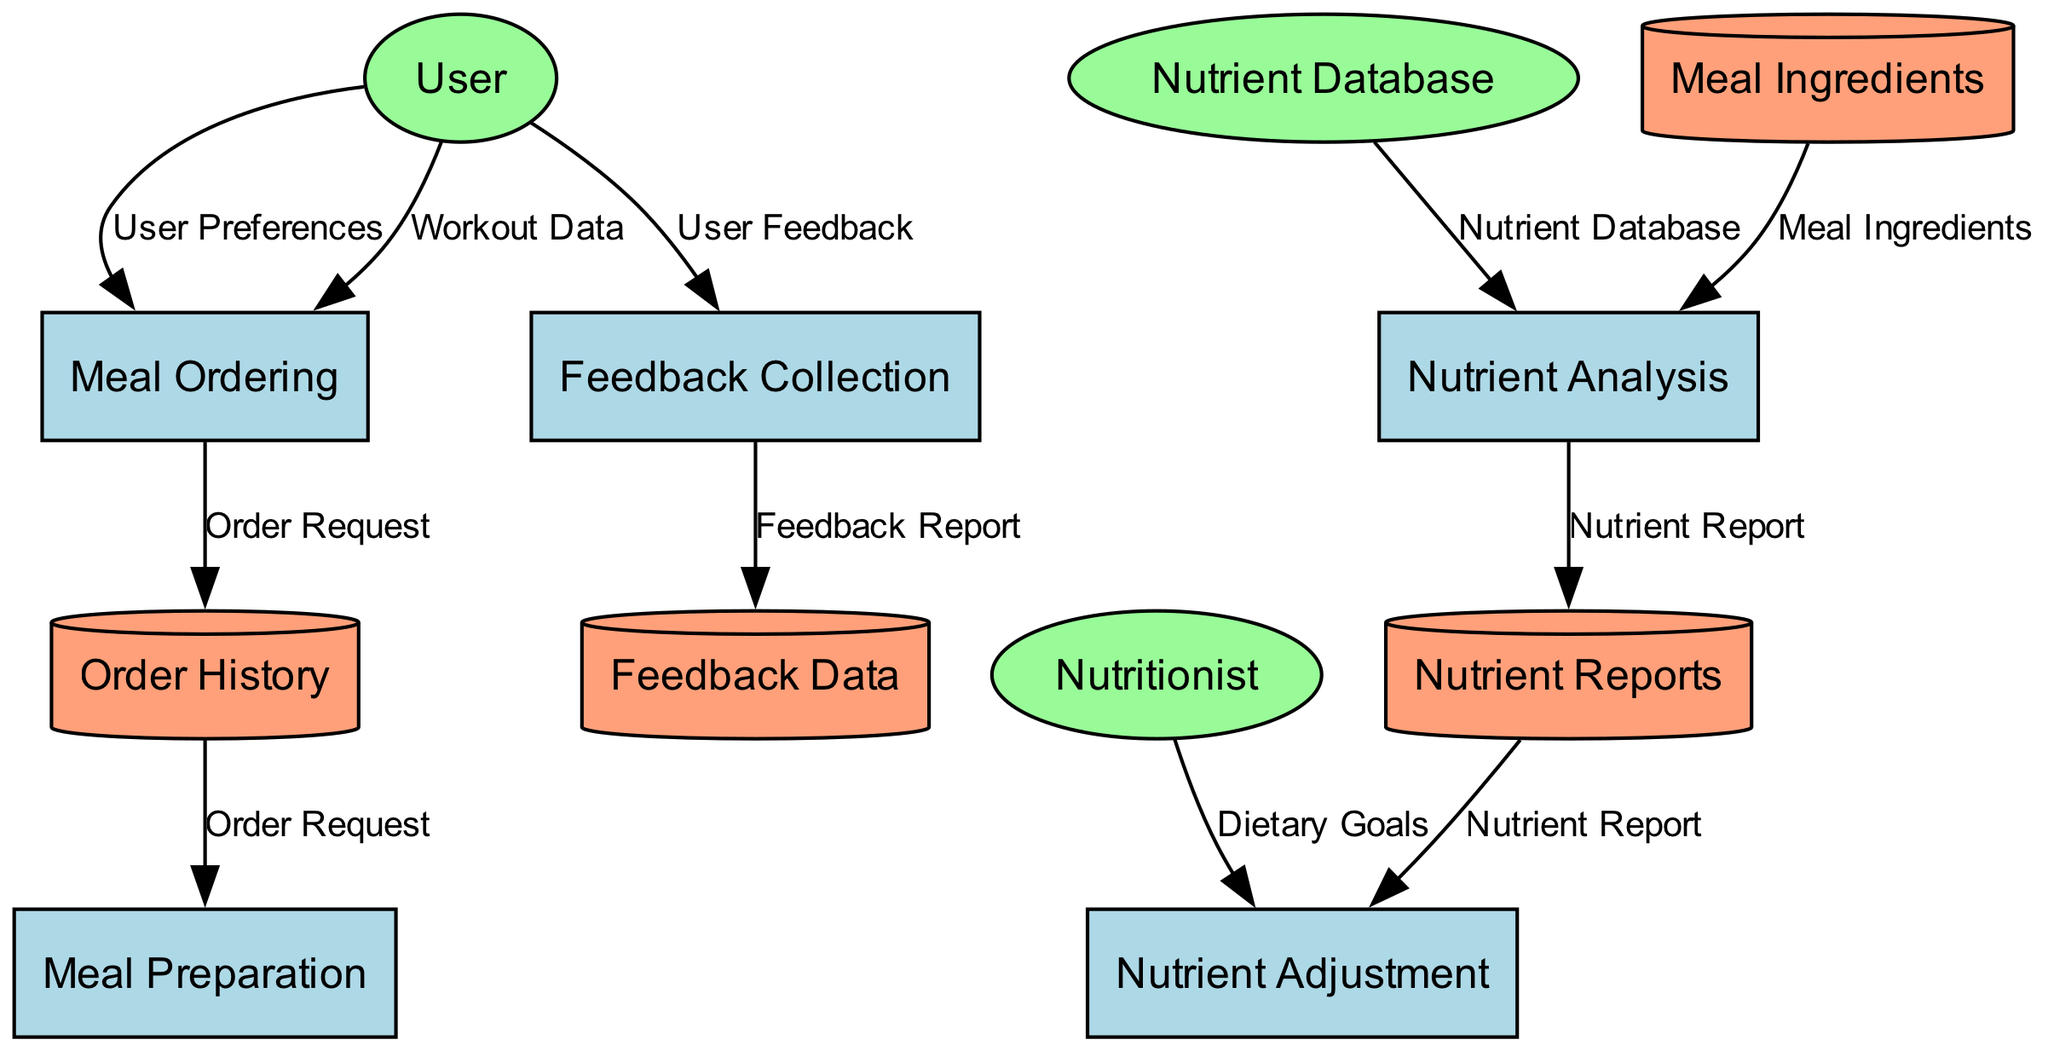What is the first process in the diagram? The first process listed in the diagram is "Meal Ordering," which is labeled as P1. This is identified by looking at the processes in the diagram and noting their order.
Answer: Meal Ordering How many external entities are present in the diagram? The diagram includes three external entities: User, Nutritionist, and Nutrient Database. They can be counted directly from the external entities section of the diagram.
Answer: Three What does the "Nutrient Analysis" process output? The "Nutrient Analysis" process outputs a "Nutrient Report," which is shown as the output of P2 in the processes section.
Answer: Nutrient Report Which process collects user feedback? The process that collects user feedback is "Feedback Collection," identified as P5 in the diagram. This is indicated by the list of processes, where P5 explicitly states its function.
Answer: Feedback Collection What type of data is stored in the "Meal Ingredients" data store? The "Meal Ingredients" data store contains "Meal Ingredients," which is precisely stated as its output. This can be verified by looking at the data stores listed in the diagram.
Answer: Meal Ingredients What input does the "Nutrient Adjustment" process require from the "Nutrient Reports" data store? The "Nutrient Adjustment" process requires a "Nutrient Report," which it draws from the "Nutrient Reports" data store. This is established by checking the inputs and their corresponding data stores.
Answer: Nutrient Report What is the output of the "Meal Preparation" process? The output of the "Meal Preparation" process is a "Prepared Meal." This is shown as the output of P4 in the processes section of the diagram.
Answer: Prepared Meal Which external entity provides dietary goals for nutrient adjustment? The external entity that provides dietary goals is the "Nutritionist." This can be confirmed by identifying the outputs of E2 in the external entities section.
Answer: Nutritionist How many processes take the "Order Request" as an input? Two processes use "Order Request" as an input: "Meal Preparation" (P4) and "Order History" (D2). This is confirmed by evaluating the inputs listed for each process and the data stores.
Answer: Two 